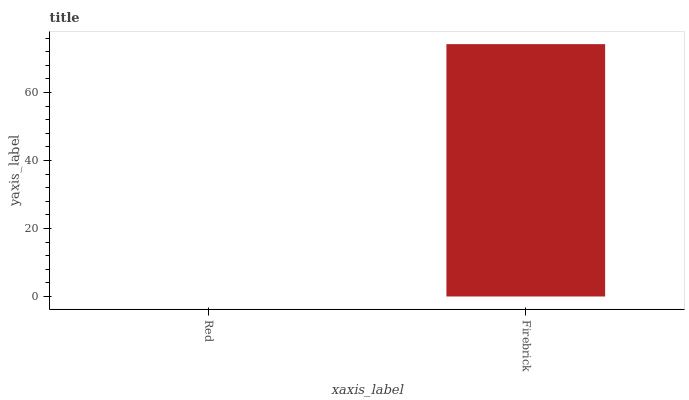Is Red the minimum?
Answer yes or no. Yes. Is Firebrick the maximum?
Answer yes or no. Yes. Is Firebrick the minimum?
Answer yes or no. No. Is Firebrick greater than Red?
Answer yes or no. Yes. Is Red less than Firebrick?
Answer yes or no. Yes. Is Red greater than Firebrick?
Answer yes or no. No. Is Firebrick less than Red?
Answer yes or no. No. Is Firebrick the high median?
Answer yes or no. Yes. Is Red the low median?
Answer yes or no. Yes. Is Red the high median?
Answer yes or no. No. Is Firebrick the low median?
Answer yes or no. No. 